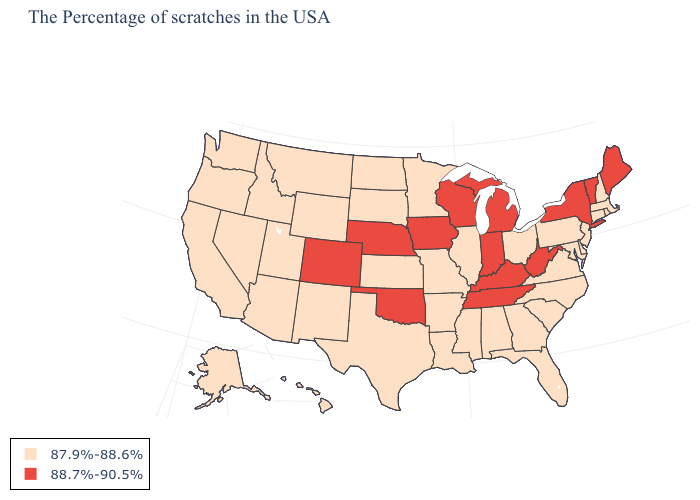Does Alabama have the lowest value in the USA?
Be succinct. Yes. Name the states that have a value in the range 87.9%-88.6%?
Give a very brief answer. Massachusetts, Rhode Island, New Hampshire, Connecticut, New Jersey, Delaware, Maryland, Pennsylvania, Virginia, North Carolina, South Carolina, Ohio, Florida, Georgia, Alabama, Illinois, Mississippi, Louisiana, Missouri, Arkansas, Minnesota, Kansas, Texas, South Dakota, North Dakota, Wyoming, New Mexico, Utah, Montana, Arizona, Idaho, Nevada, California, Washington, Oregon, Alaska, Hawaii. Name the states that have a value in the range 87.9%-88.6%?
Concise answer only. Massachusetts, Rhode Island, New Hampshire, Connecticut, New Jersey, Delaware, Maryland, Pennsylvania, Virginia, North Carolina, South Carolina, Ohio, Florida, Georgia, Alabama, Illinois, Mississippi, Louisiana, Missouri, Arkansas, Minnesota, Kansas, Texas, South Dakota, North Dakota, Wyoming, New Mexico, Utah, Montana, Arizona, Idaho, Nevada, California, Washington, Oregon, Alaska, Hawaii. Name the states that have a value in the range 88.7%-90.5%?
Write a very short answer. Maine, Vermont, New York, West Virginia, Michigan, Kentucky, Indiana, Tennessee, Wisconsin, Iowa, Nebraska, Oklahoma, Colorado. Does Virginia have the lowest value in the USA?
Be succinct. Yes. Name the states that have a value in the range 88.7%-90.5%?
Be succinct. Maine, Vermont, New York, West Virginia, Michigan, Kentucky, Indiana, Tennessee, Wisconsin, Iowa, Nebraska, Oklahoma, Colorado. Name the states that have a value in the range 88.7%-90.5%?
Write a very short answer. Maine, Vermont, New York, West Virginia, Michigan, Kentucky, Indiana, Tennessee, Wisconsin, Iowa, Nebraska, Oklahoma, Colorado. Among the states that border Maine , which have the lowest value?
Concise answer only. New Hampshire. Is the legend a continuous bar?
Write a very short answer. No. What is the value of Georgia?
Quick response, please. 87.9%-88.6%. Does Minnesota have the same value as Wisconsin?
Short answer required. No. Among the states that border Wyoming , does Colorado have the highest value?
Quick response, please. Yes. What is the value of Rhode Island?
Answer briefly. 87.9%-88.6%. Name the states that have a value in the range 87.9%-88.6%?
Give a very brief answer. Massachusetts, Rhode Island, New Hampshire, Connecticut, New Jersey, Delaware, Maryland, Pennsylvania, Virginia, North Carolina, South Carolina, Ohio, Florida, Georgia, Alabama, Illinois, Mississippi, Louisiana, Missouri, Arkansas, Minnesota, Kansas, Texas, South Dakota, North Dakota, Wyoming, New Mexico, Utah, Montana, Arizona, Idaho, Nevada, California, Washington, Oregon, Alaska, Hawaii. What is the highest value in the West ?
Be succinct. 88.7%-90.5%. 